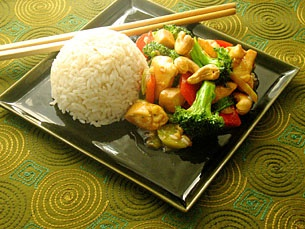Describe the objects in this image and their specific colors. I can see dining table in khaki, olive, and black tones, broccoli in khaki, black, olive, and darkgreen tones, broccoli in khaki and olive tones, broccoli in khaki and olive tones, and carrot in khaki, brown, maroon, and red tones in this image. 